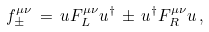Convert formula to latex. <formula><loc_0><loc_0><loc_500><loc_500>f _ { \pm } ^ { \mu \nu } \, = \, u F _ { L } ^ { \mu \nu } u ^ { \dagger } \, \pm \, u ^ { \dagger } F _ { R } ^ { \mu \nu } u \, ,</formula> 